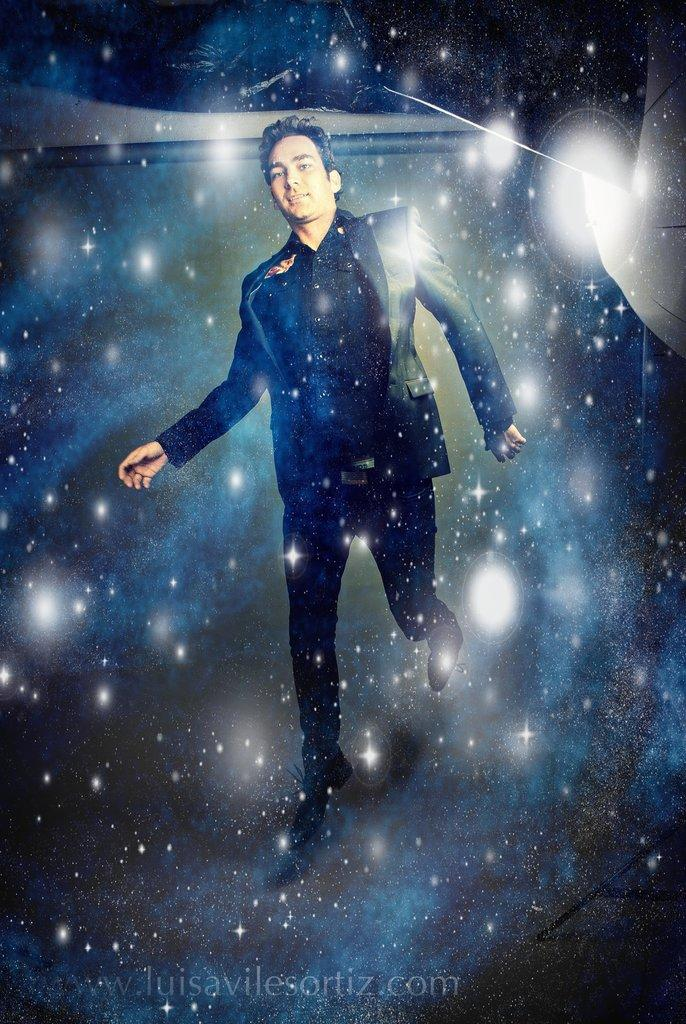What is present in the image? There is a man in the image. Can you describe any additional features of the image? There is a watermark on the image. What nation is the man from in the image? The provided facts do not give any information about the man's nationality, so it cannot be determined from the image. What type of pen is the man holding in the image? There is no pen present in the image, and the man is not holding anything. 